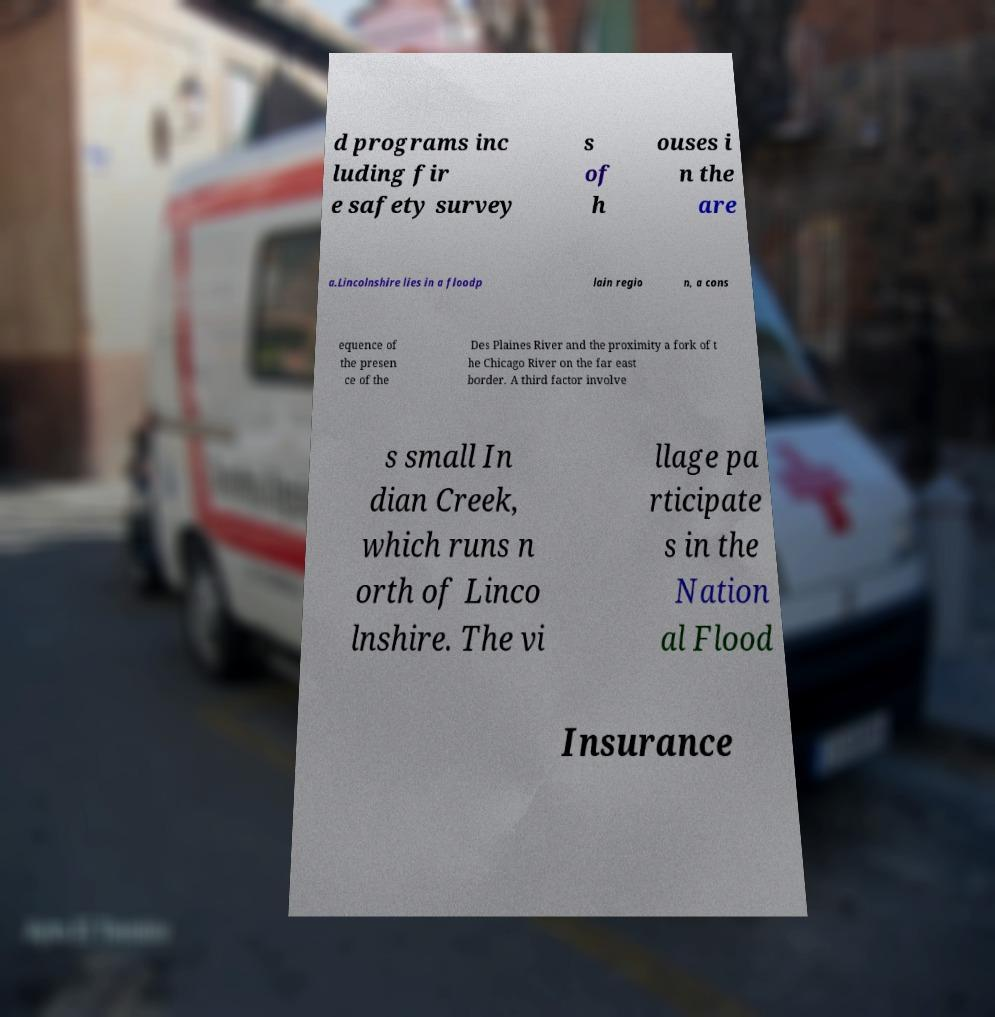Could you extract and type out the text from this image? d programs inc luding fir e safety survey s of h ouses i n the are a.Lincolnshire lies in a floodp lain regio n, a cons equence of the presen ce of the Des Plaines River and the proximity a fork of t he Chicago River on the far east border. A third factor involve s small In dian Creek, which runs n orth of Linco lnshire. The vi llage pa rticipate s in the Nation al Flood Insurance 